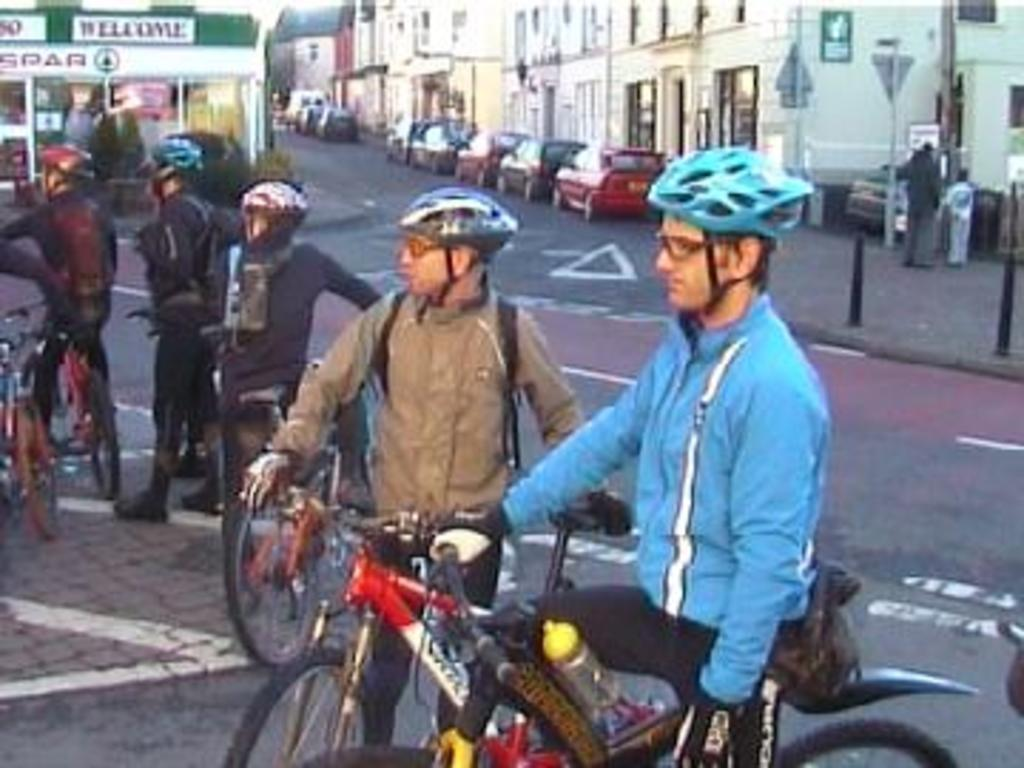What is the main subject of the image? The main subject of the image is a group of men. What are some of the men doing in the image? Some men are sitting on bicycles, while others are standing. What can be seen in the background of the image? There are buildings, a road, poles, and other objects in the background of the image. How many matches are being used by the men in the image? There are no matches present in the image; the men are either sitting on bicycles or standing. 